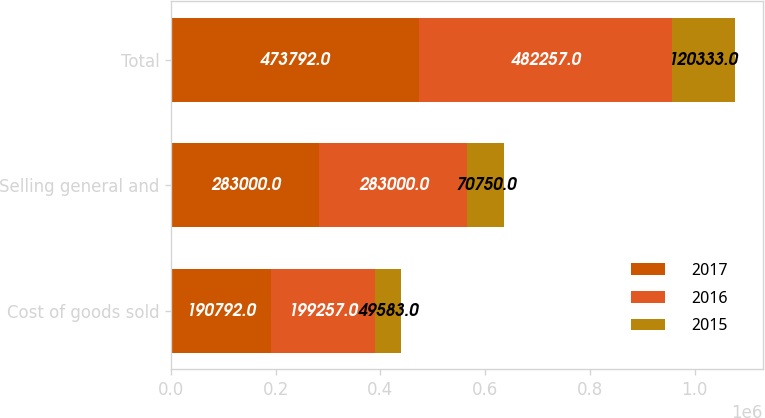Convert chart. <chart><loc_0><loc_0><loc_500><loc_500><stacked_bar_chart><ecel><fcel>Cost of goods sold<fcel>Selling general and<fcel>Total<nl><fcel>2017<fcel>190792<fcel>283000<fcel>473792<nl><fcel>2016<fcel>199257<fcel>283000<fcel>482257<nl><fcel>2015<fcel>49583<fcel>70750<fcel>120333<nl></chart> 